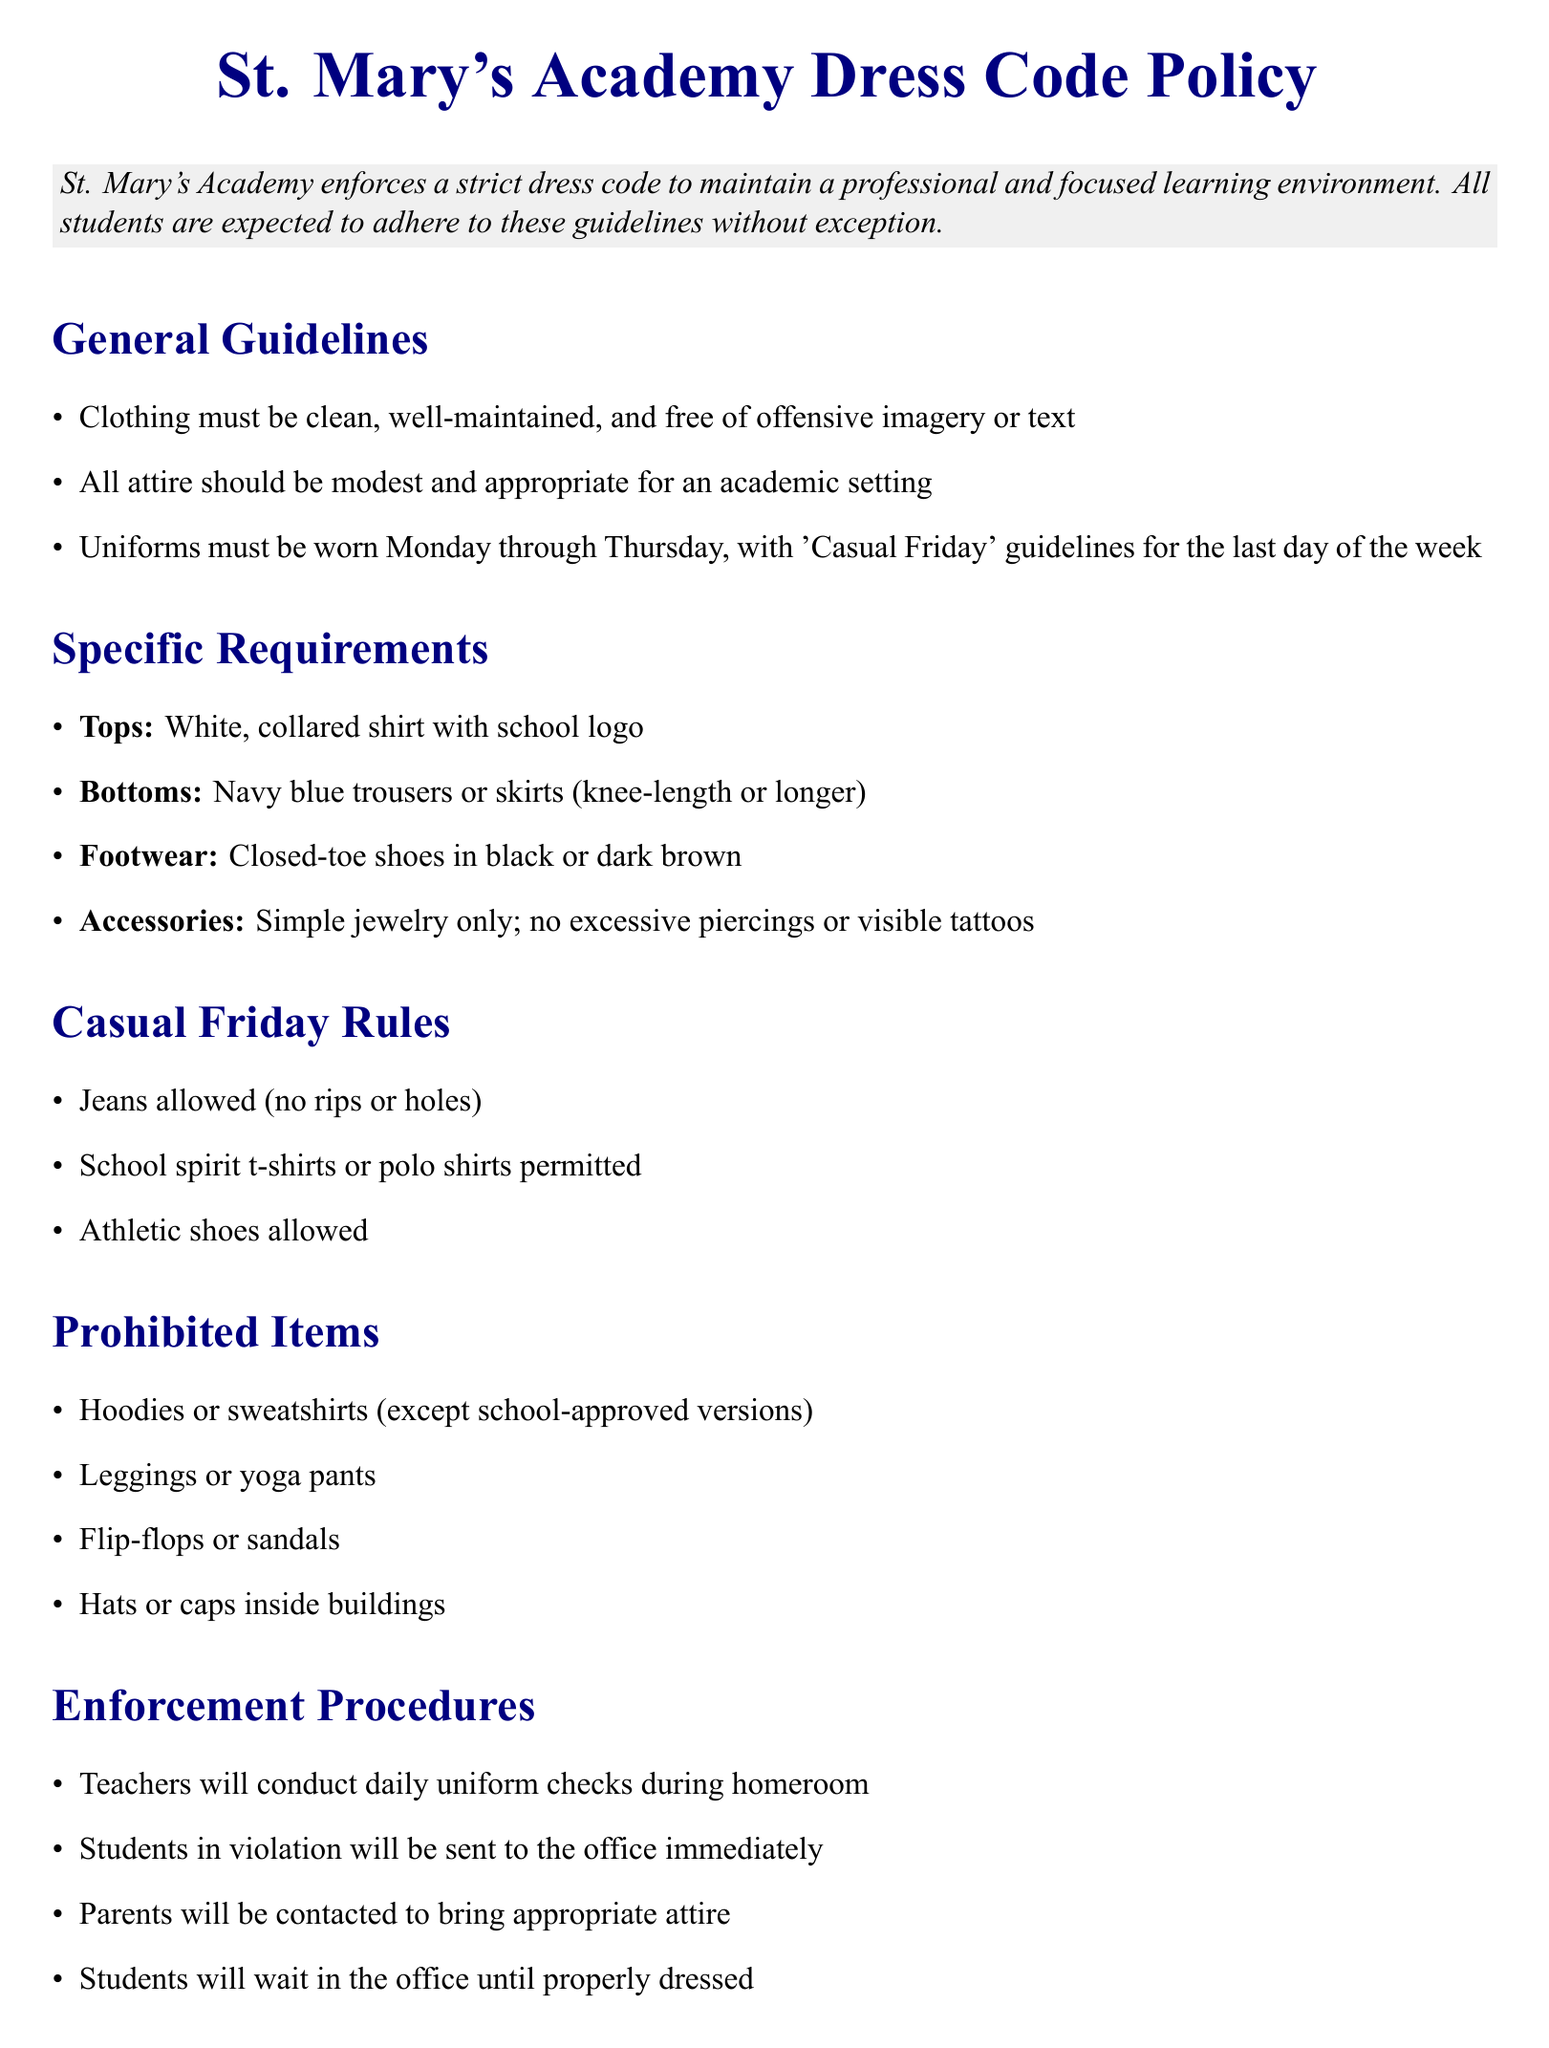What is the school's name? The school's name is stated at the beginning of the document.
Answer: St. Mary's Academy What days are uniforms required? The document specifies the days on which uniforms should be worn.
Answer: Monday through Thursday What type of footwear is permitted? This information is included under the specific requirements for footwear.
Answer: Closed-toe shoes in black or dark brown What is the consequence for a first offense? The consequences for violations are detailed in the document, specifically for the first offense.
Answer: Written warning What are the casual Friday rules regarding jeans? The casual Friday rules outline the conditions for wearing jeans.
Answer: No rips or holes What is the policy on hoodies? The prohibited items section mentions guidelines regarding hoodies.
Answer: Except school-approved versions How will violations be enforced? The enforcement procedures detail how violations will be managed.
Answer: Teachers will conduct daily uniform checks What might happen after repeated offenses? The consequences section hints at actions taken after multiple offenses.
Answer: Possible suspension or other disciplinary action 